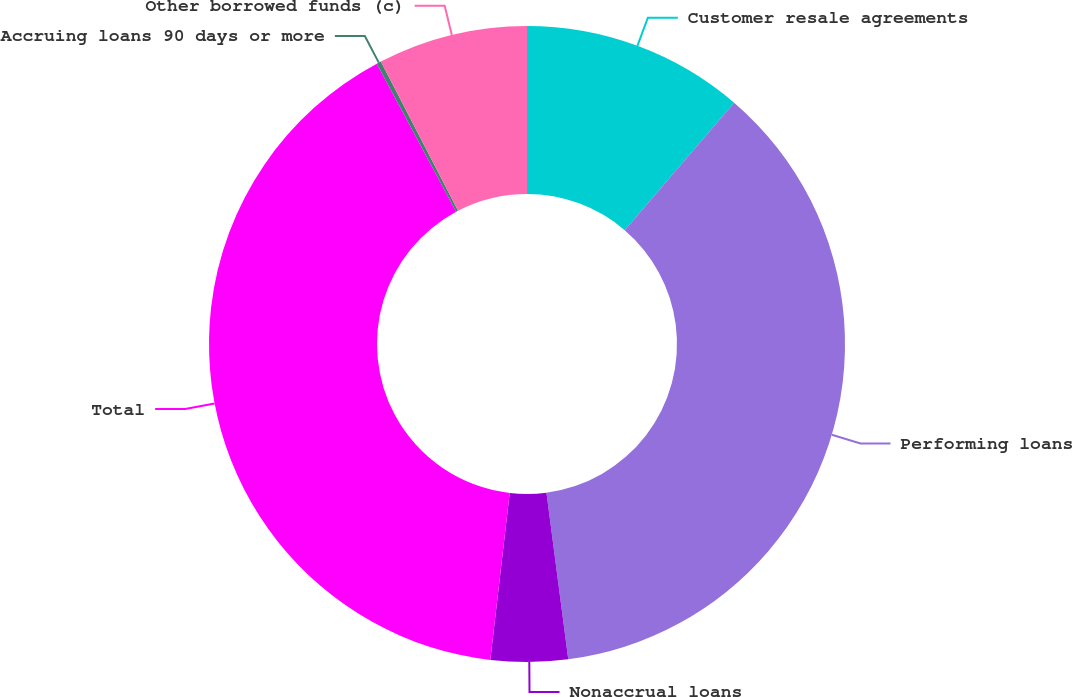Convert chart to OTSL. <chart><loc_0><loc_0><loc_500><loc_500><pie_chart><fcel>Customer resale agreements<fcel>Performing loans<fcel>Nonaccrual loans<fcel>Total<fcel>Accruing loans 90 days or more<fcel>Other borrowed funds (c)<nl><fcel>11.29%<fcel>36.64%<fcel>3.91%<fcel>40.33%<fcel>0.23%<fcel>7.6%<nl></chart> 